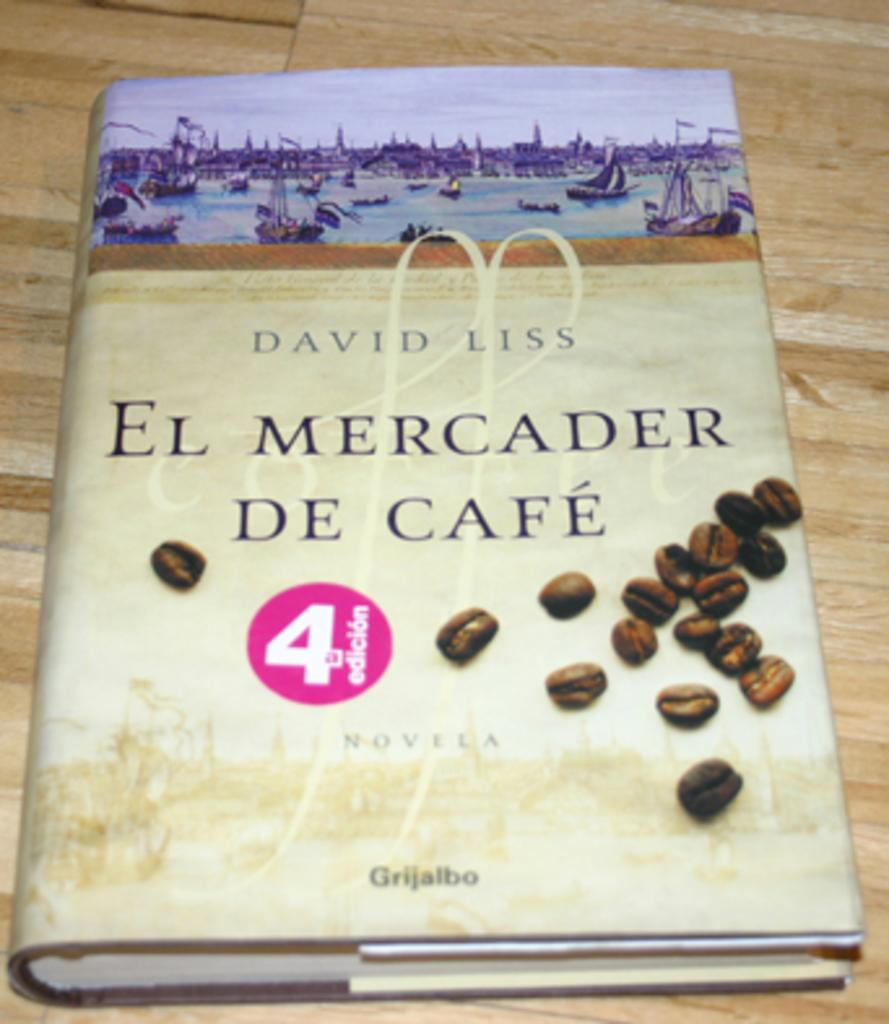<image>
Write a terse but informative summary of the picture. a book that says el mercader de cafe on the cover of it 